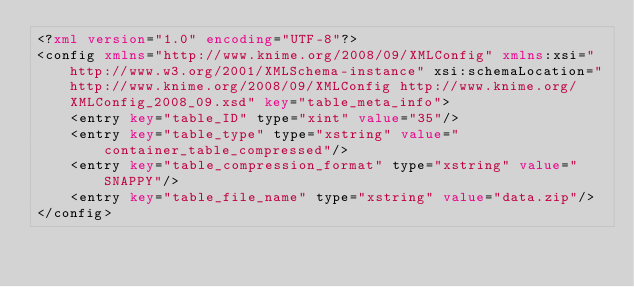Convert code to text. <code><loc_0><loc_0><loc_500><loc_500><_XML_><?xml version="1.0" encoding="UTF-8"?>
<config xmlns="http://www.knime.org/2008/09/XMLConfig" xmlns:xsi="http://www.w3.org/2001/XMLSchema-instance" xsi:schemaLocation="http://www.knime.org/2008/09/XMLConfig http://www.knime.org/XMLConfig_2008_09.xsd" key="table_meta_info">
    <entry key="table_ID" type="xint" value="35"/>
    <entry key="table_type" type="xstring" value="container_table_compressed"/>
    <entry key="table_compression_format" type="xstring" value="SNAPPY"/>
    <entry key="table_file_name" type="xstring" value="data.zip"/>
</config>
</code> 